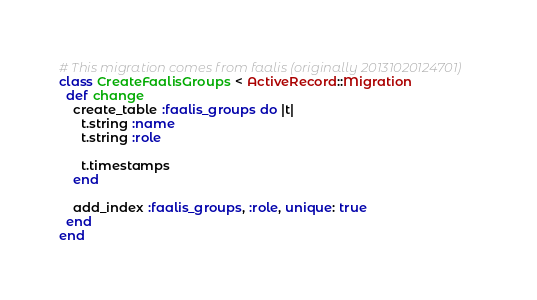<code> <loc_0><loc_0><loc_500><loc_500><_Ruby_># This migration comes from faalis (originally 20131020124701)
class CreateFaalisGroups < ActiveRecord::Migration
  def change
    create_table :faalis_groups do |t|
      t.string :name
      t.string :role

      t.timestamps
    end

    add_index :faalis_groups, :role, unique: true
  end
end
</code> 